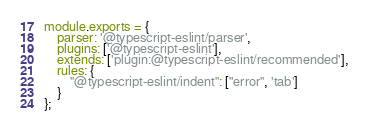<code> <loc_0><loc_0><loc_500><loc_500><_JavaScript_>module.exports = {
	parser: '@typescript-eslint/parser',
	plugins: ['@typescript-eslint'],
	extends: ['plugin:@typescript-eslint/recommended'],
	rules: {
		"@typescript-eslint/indent": ["error", 'tab']
	}
};</code> 